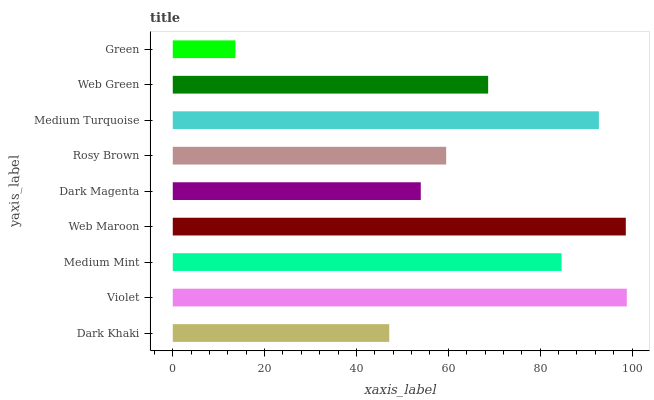Is Green the minimum?
Answer yes or no. Yes. Is Violet the maximum?
Answer yes or no. Yes. Is Medium Mint the minimum?
Answer yes or no. No. Is Medium Mint the maximum?
Answer yes or no. No. Is Violet greater than Medium Mint?
Answer yes or no. Yes. Is Medium Mint less than Violet?
Answer yes or no. Yes. Is Medium Mint greater than Violet?
Answer yes or no. No. Is Violet less than Medium Mint?
Answer yes or no. No. Is Web Green the high median?
Answer yes or no. Yes. Is Web Green the low median?
Answer yes or no. Yes. Is Web Maroon the high median?
Answer yes or no. No. Is Rosy Brown the low median?
Answer yes or no. No. 